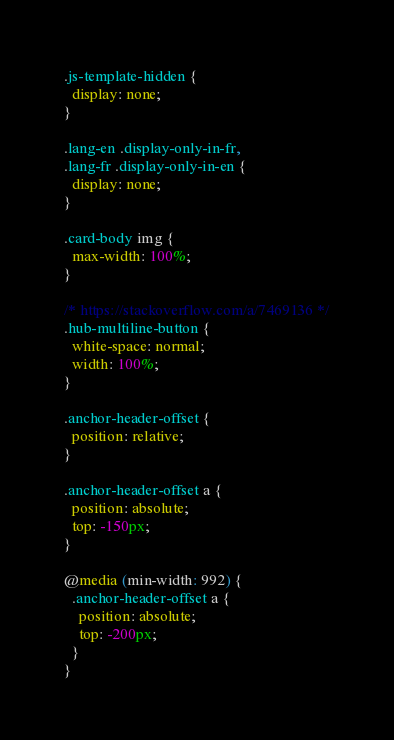<code> <loc_0><loc_0><loc_500><loc_500><_CSS_>.js-template-hidden {
  display: none;
}

.lang-en .display-only-in-fr,
.lang-fr .display-only-in-en {
  display: none;
}

.card-body img {
  max-width: 100%;
}

/* https://stackoverflow.com/a/7469136 */
.hub-multiline-button {
  white-space: normal;
  width: 100%;
}

.anchor-header-offset {
  position: relative;
}

.anchor-header-offset a {
  position: absolute;
  top: -150px;
}

@media (min-width: 992) {
  .anchor-header-offset a {
    position: absolute;
    top: -200px;
  }
}
</code> 